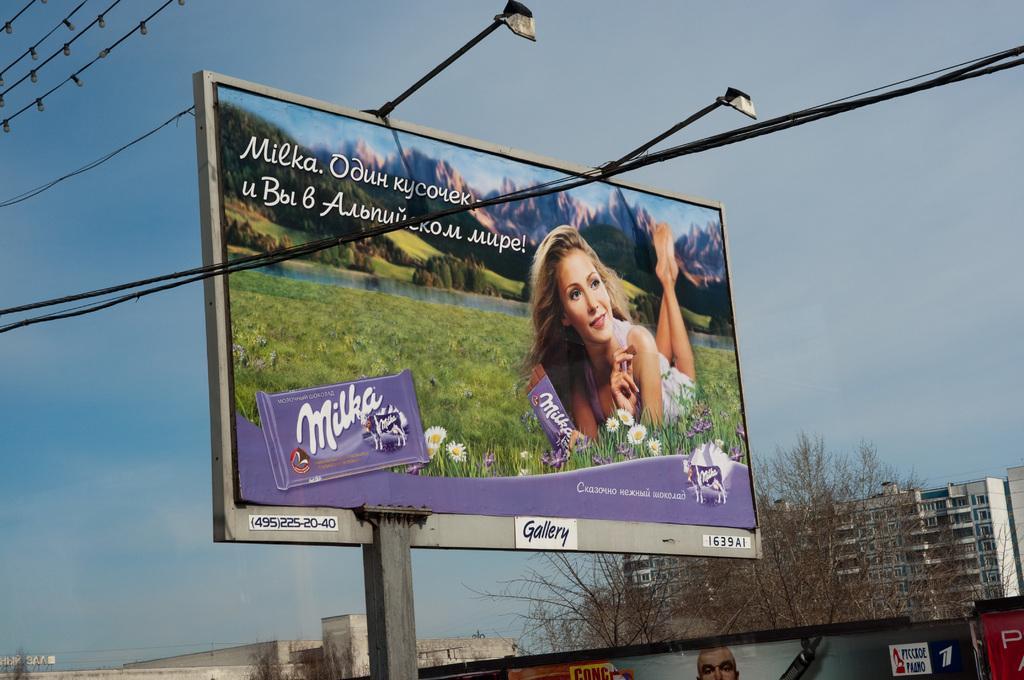Describe this image in one or two sentences. In this image there is a banner with some text and images attached to the frame and there are lights attached to the frame, there are a few cables, buildings, trees, a few posters and the sky. 